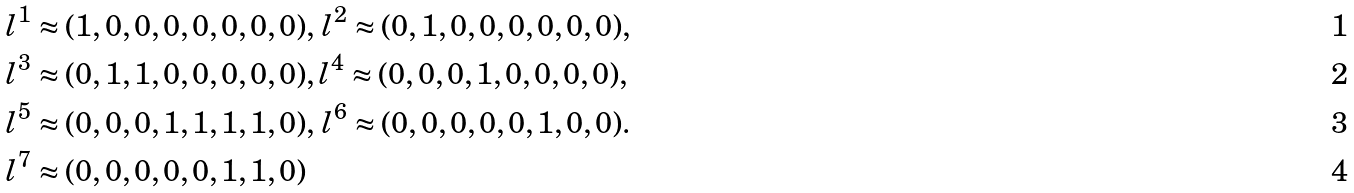<formula> <loc_0><loc_0><loc_500><loc_500>& l ^ { 1 } \approx ( 1 , 0 , 0 , 0 , 0 , 0 , 0 , 0 ) , \, l ^ { 2 } \approx ( 0 , 1 , 0 , 0 , 0 , 0 , 0 , 0 ) , \, \\ & l ^ { 3 } \approx ( 0 , 1 , 1 , 0 , 0 , 0 , 0 , 0 ) , l ^ { 4 } \approx ( 0 , 0 , 0 , 1 , 0 , 0 , 0 , 0 ) , \, \\ & l ^ { 5 } \approx ( 0 , 0 , 0 , 1 , 1 , 1 , 1 , 0 ) , \, l ^ { 6 } \approx ( 0 , 0 , 0 , 0 , 0 , 1 , 0 , 0 ) . \\ & l ^ { 7 } \approx ( 0 , 0 , 0 , 0 , 0 , 1 , 1 , 0 )</formula> 